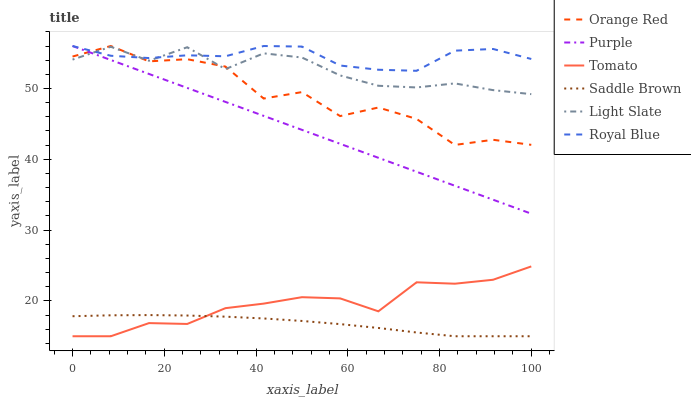Does Purple have the minimum area under the curve?
Answer yes or no. No. Does Purple have the maximum area under the curve?
Answer yes or no. No. Is Light Slate the smoothest?
Answer yes or no. No. Is Light Slate the roughest?
Answer yes or no. No. Does Purple have the lowest value?
Answer yes or no. No. Does Light Slate have the highest value?
Answer yes or no. No. Is Tomato less than Purple?
Answer yes or no. Yes. Is Purple greater than Tomato?
Answer yes or no. Yes. Does Tomato intersect Purple?
Answer yes or no. No. 